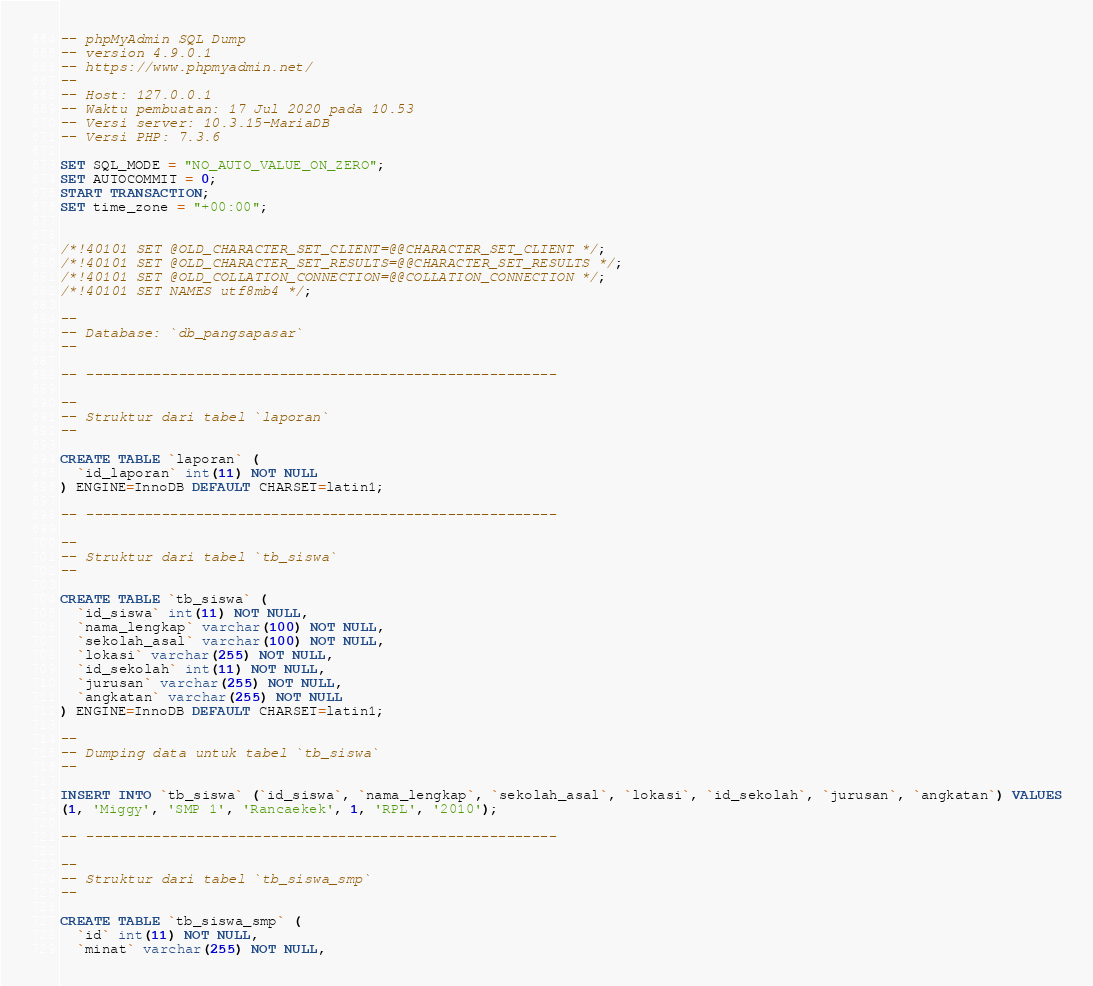<code> <loc_0><loc_0><loc_500><loc_500><_SQL_>-- phpMyAdmin SQL Dump
-- version 4.9.0.1
-- https://www.phpmyadmin.net/
--
-- Host: 127.0.0.1
-- Waktu pembuatan: 17 Jul 2020 pada 10.53
-- Versi server: 10.3.15-MariaDB
-- Versi PHP: 7.3.6

SET SQL_MODE = "NO_AUTO_VALUE_ON_ZERO";
SET AUTOCOMMIT = 0;
START TRANSACTION;
SET time_zone = "+00:00";


/*!40101 SET @OLD_CHARACTER_SET_CLIENT=@@CHARACTER_SET_CLIENT */;
/*!40101 SET @OLD_CHARACTER_SET_RESULTS=@@CHARACTER_SET_RESULTS */;
/*!40101 SET @OLD_COLLATION_CONNECTION=@@COLLATION_CONNECTION */;
/*!40101 SET NAMES utf8mb4 */;

--
-- Database: `db_pangsapasar`
--

-- --------------------------------------------------------

--
-- Struktur dari tabel `laporan`
--

CREATE TABLE `laporan` (
  `id_laporan` int(11) NOT NULL
) ENGINE=InnoDB DEFAULT CHARSET=latin1;

-- --------------------------------------------------------

--
-- Struktur dari tabel `tb_siswa`
--

CREATE TABLE `tb_siswa` (
  `id_siswa` int(11) NOT NULL,
  `nama_lengkap` varchar(100) NOT NULL,
  `sekolah_asal` varchar(100) NOT NULL,
  `lokasi` varchar(255) NOT NULL,
  `id_sekolah` int(11) NOT NULL,
  `jurusan` varchar(255) NOT NULL,
  `angkatan` varchar(255) NOT NULL
) ENGINE=InnoDB DEFAULT CHARSET=latin1;

--
-- Dumping data untuk tabel `tb_siswa`
--

INSERT INTO `tb_siswa` (`id_siswa`, `nama_lengkap`, `sekolah_asal`, `lokasi`, `id_sekolah`, `jurusan`, `angkatan`) VALUES
(1, 'Miggy', 'SMP 1', 'Rancaekek', 1, 'RPL', '2010');

-- --------------------------------------------------------

--
-- Struktur dari tabel `tb_siswa_smp`
--

CREATE TABLE `tb_siswa_smp` (
  `id` int(11) NOT NULL,
  `minat` varchar(255) NOT NULL,</code> 